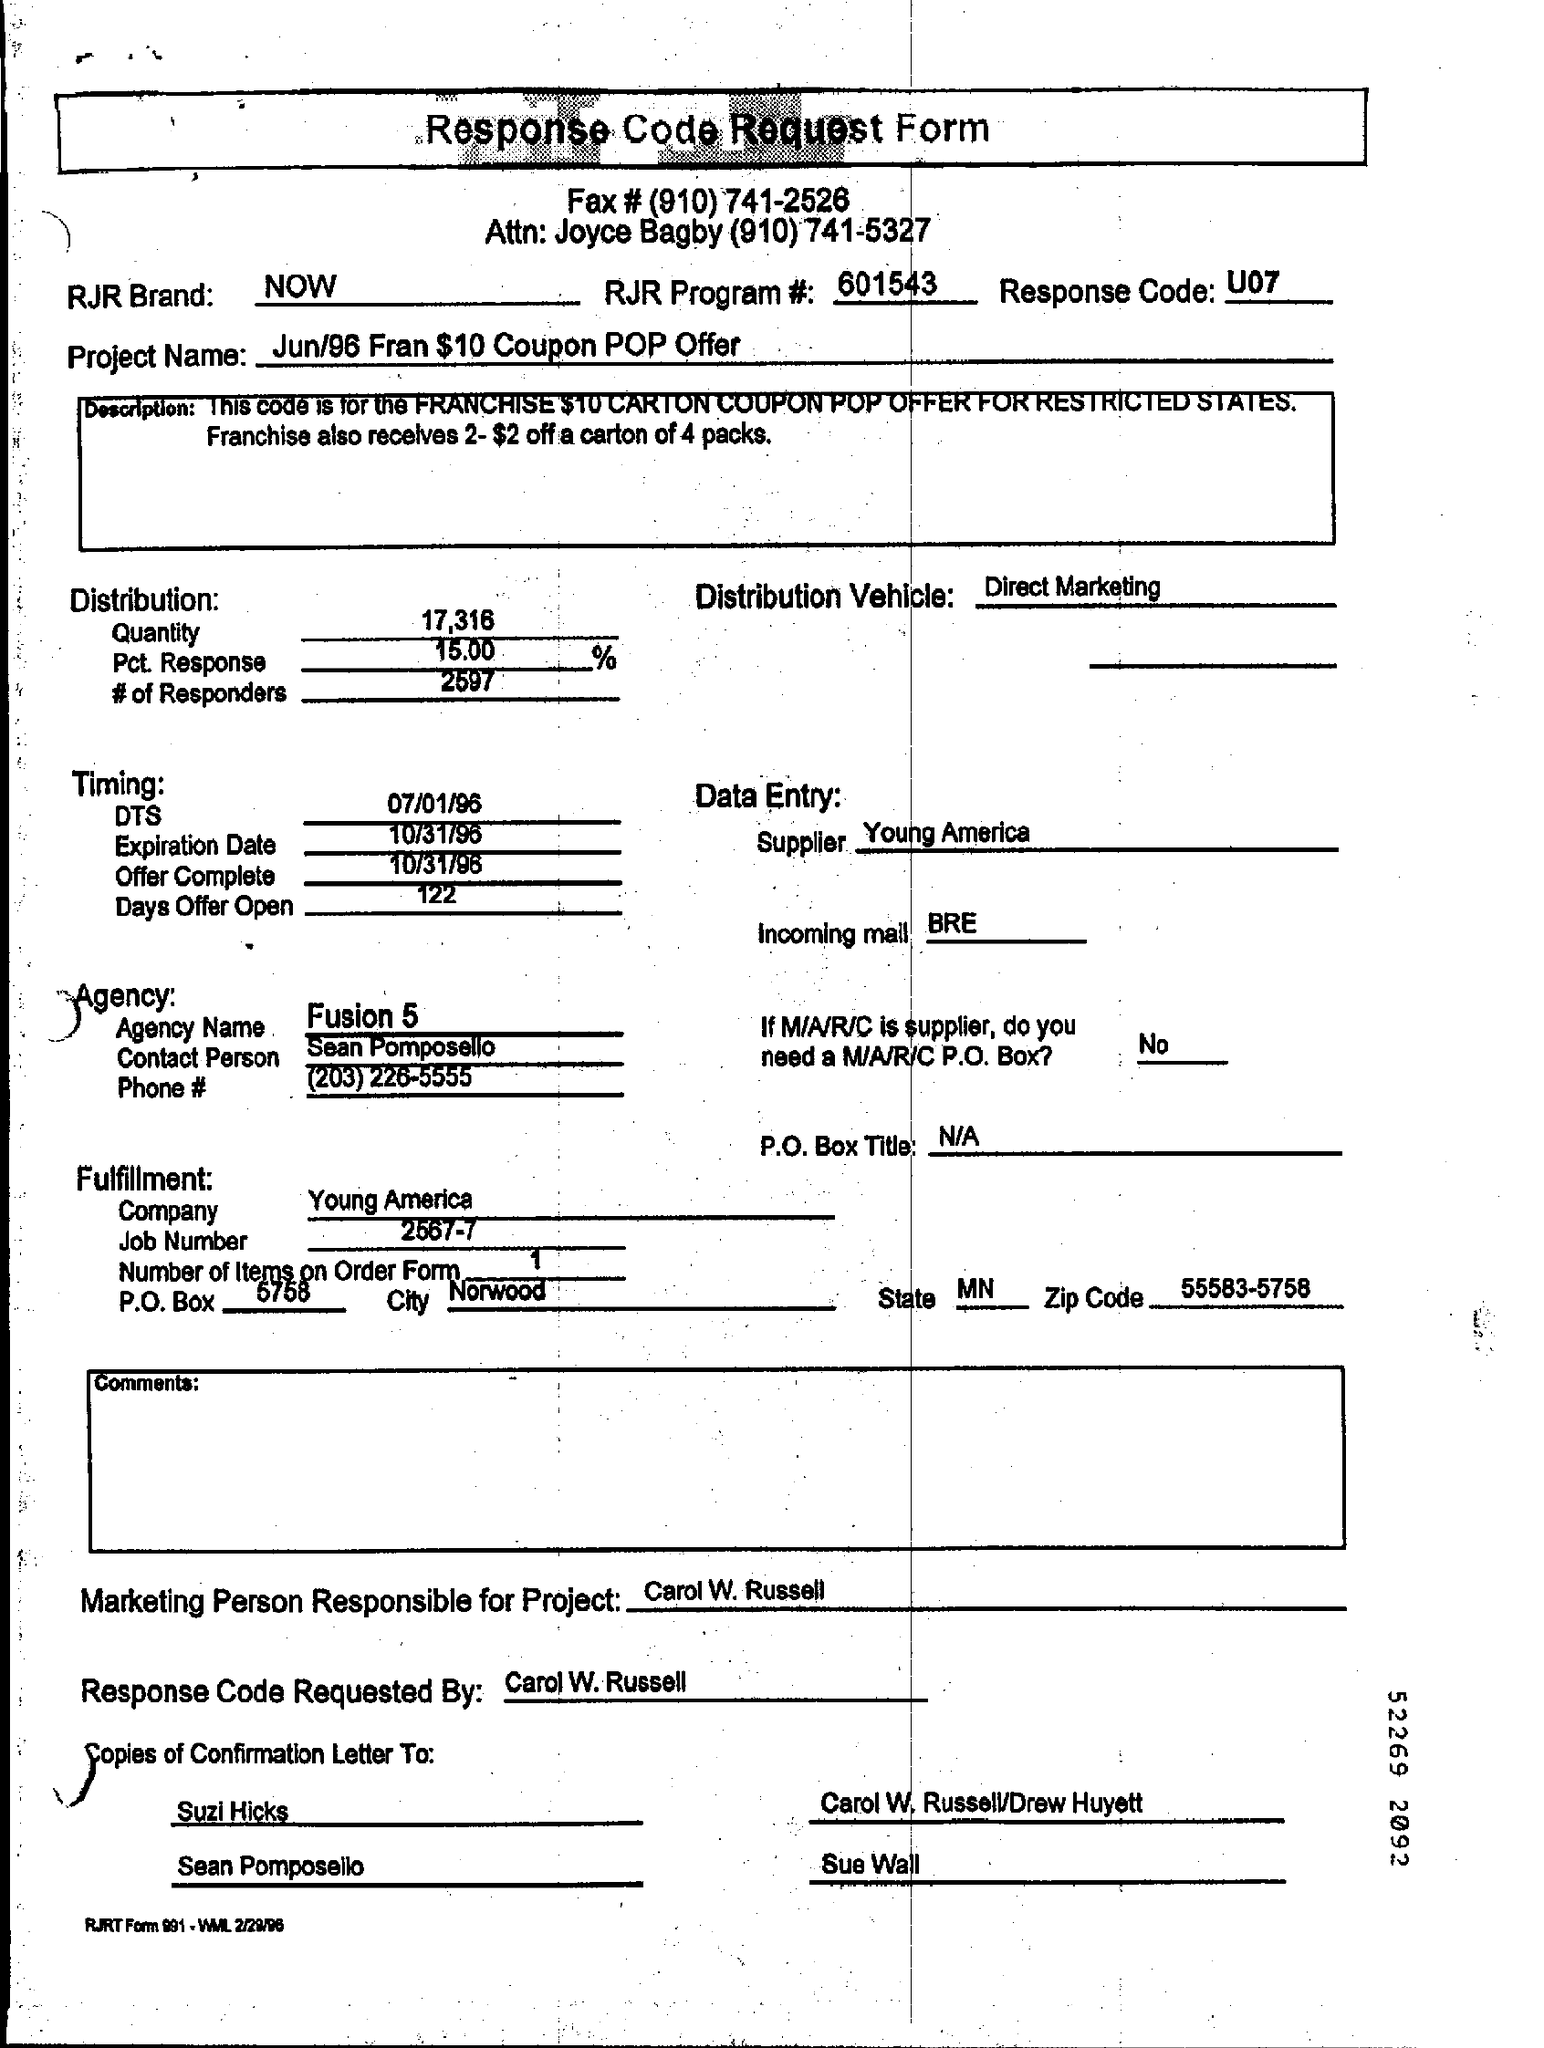Give some essential details in this illustration. This is a response code request form. The response code given is U07.. The Jun/96 Fran $10 Coupon POP offer is the name of the project. 